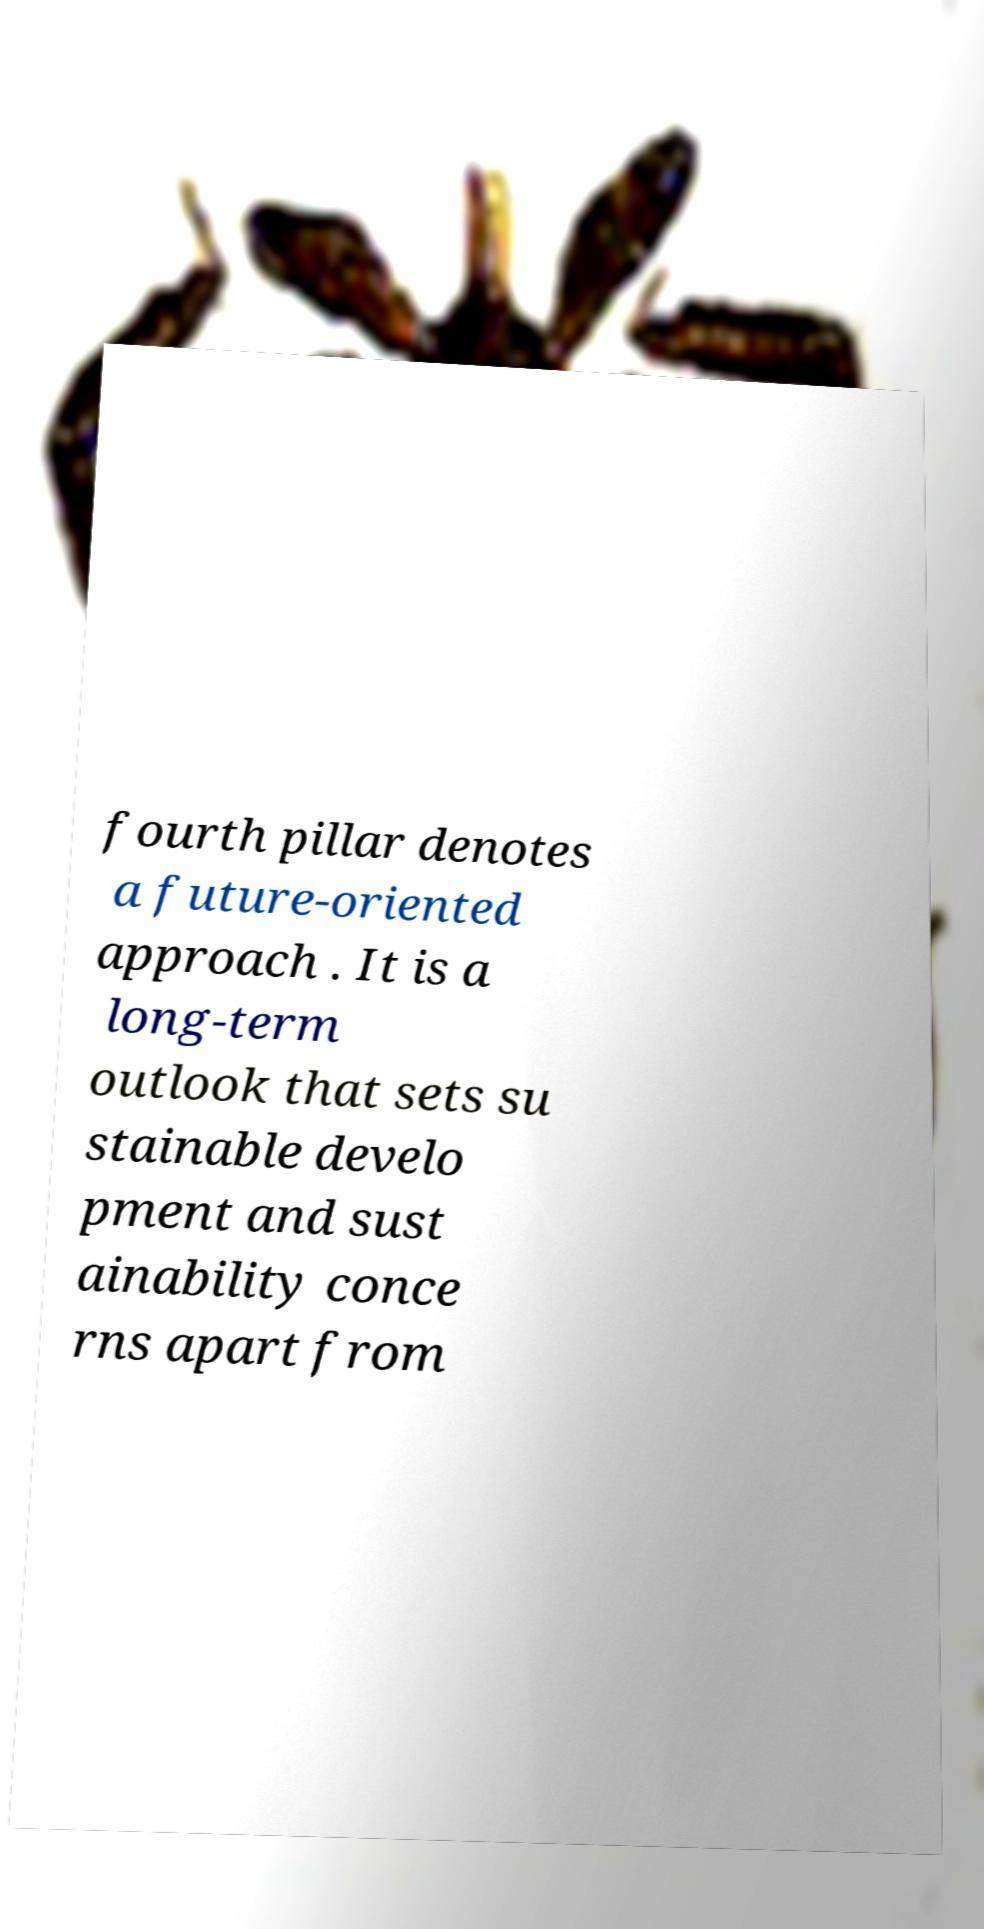Can you read and provide the text displayed in the image?This photo seems to have some interesting text. Can you extract and type it out for me? fourth pillar denotes a future-oriented approach . It is a long-term outlook that sets su stainable develo pment and sust ainability conce rns apart from 